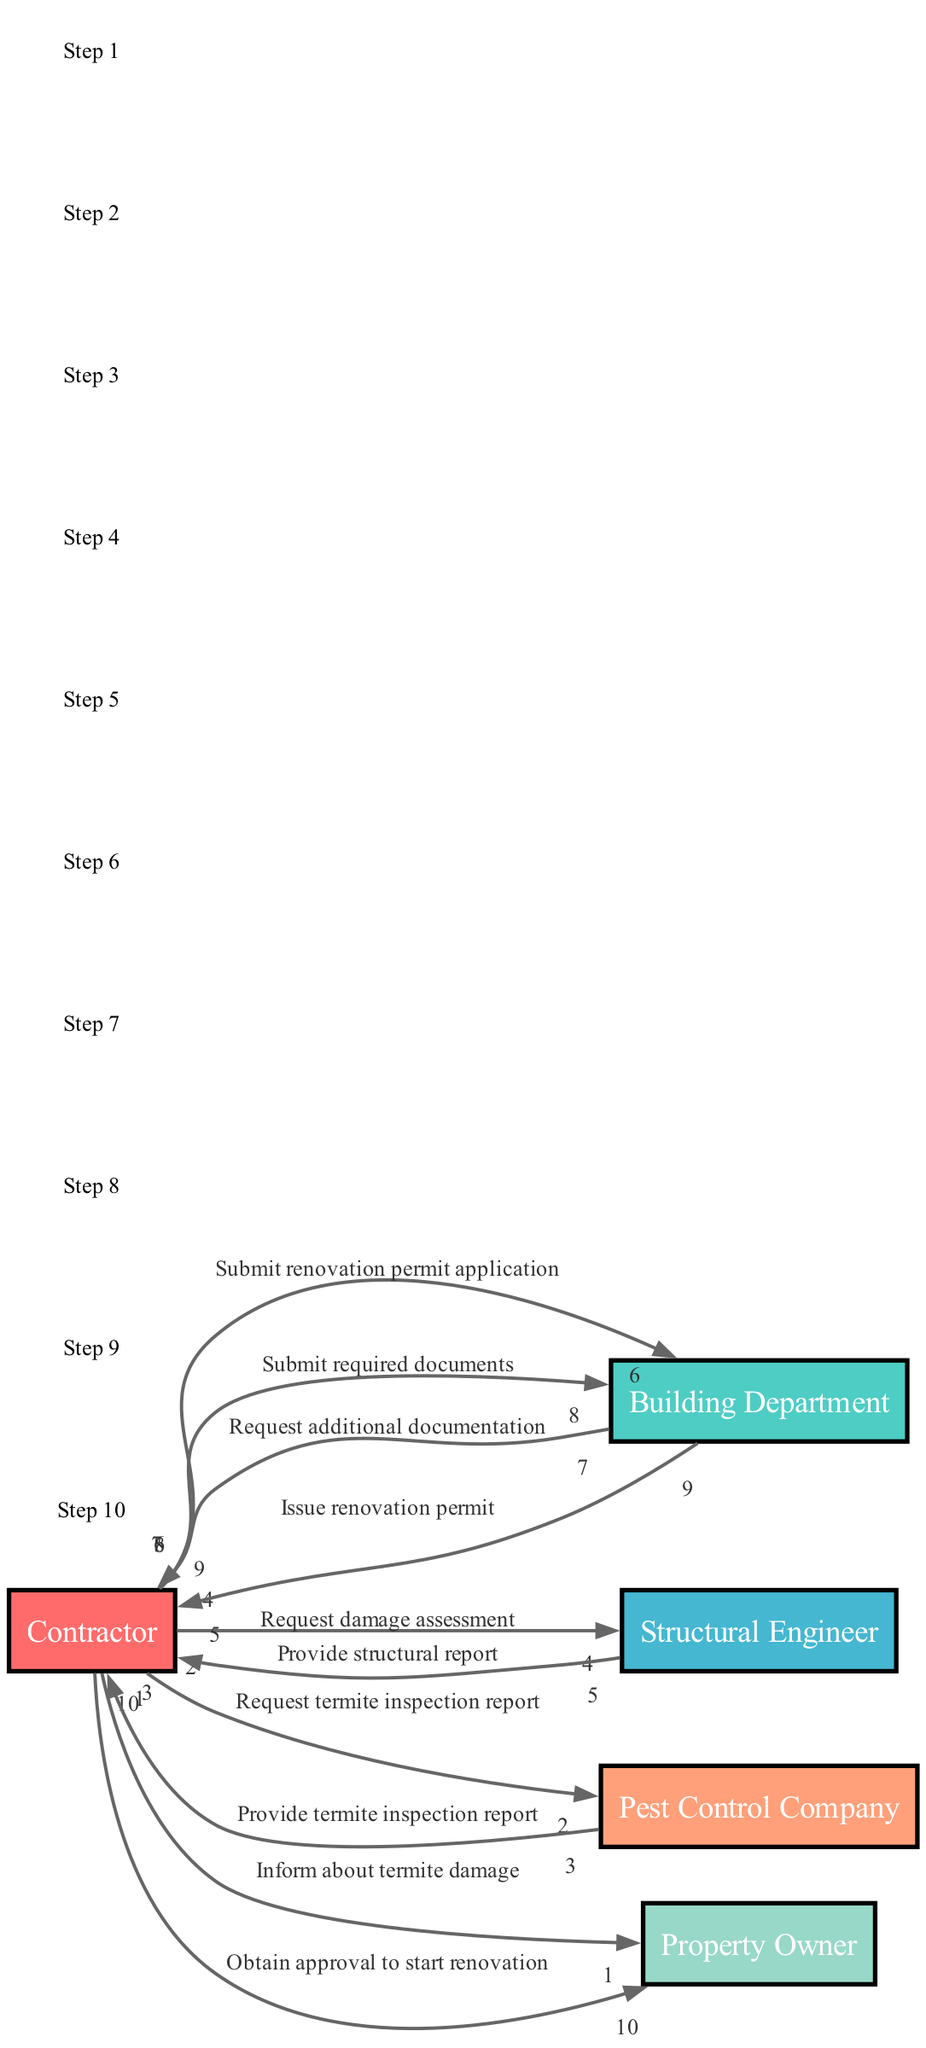What is the first action taken in the workflow? The first action is initiated by the Contractor when they inform the Property Owner about the termite damage. This can be confirmed as the first step in the sequence.
Answer: Inform about termite damage How many actors are involved in the diagram? The diagram lists a total of five actors involved in the workflow: Contractor, Building Department, Structural Engineer, Pest Control Company, and Property Owner. Counting visually, we find five distinct entries.
Answer: 5 What document is requested from the Pest Control Company? The Contractor requests a termite inspection report from the Pest Control Company. This request is explicitly mentioned as part of the second interaction in the sequence.
Answer: Termite inspection report What does the Building Department request after the Contractor submits the permit application? After the Contractor submits the renovation permit application, the Building Department requests additional documentation from the Contractor. This is the interaction specified in the seventh step of the sequence.
Answer: Additional documentation What is the final action taken by the Contractor in the workflow? The final action taken is for the Contractor to obtain approval to start the renovation from the Property Owner. This last interaction marks the conclusion of the workflow sequence.
Answer: Obtain approval to start renovation What is the order of the interaction between the Contractor and the Structural Engineer? The Contractor first requests a damage assessment from the Structural Engineer, followed by the Structural Engineer providing a structural report. This order is clearly defined in the fourth and fifth steps of the sequence.
Answer: Request damage assessment, Provide structural report How many steps are involved in the entire workflow? Counting the sequence of interactions listed, there are a total of ten steps involved in completing the workflow for obtaining necessary permits and approvals.
Answer: 10 Which actor issues the renovation permit? The Building Department is responsible for issuing the renovation permit to the Contractor, as stated in the eighth step of the sequence.
Answer: Building Department 